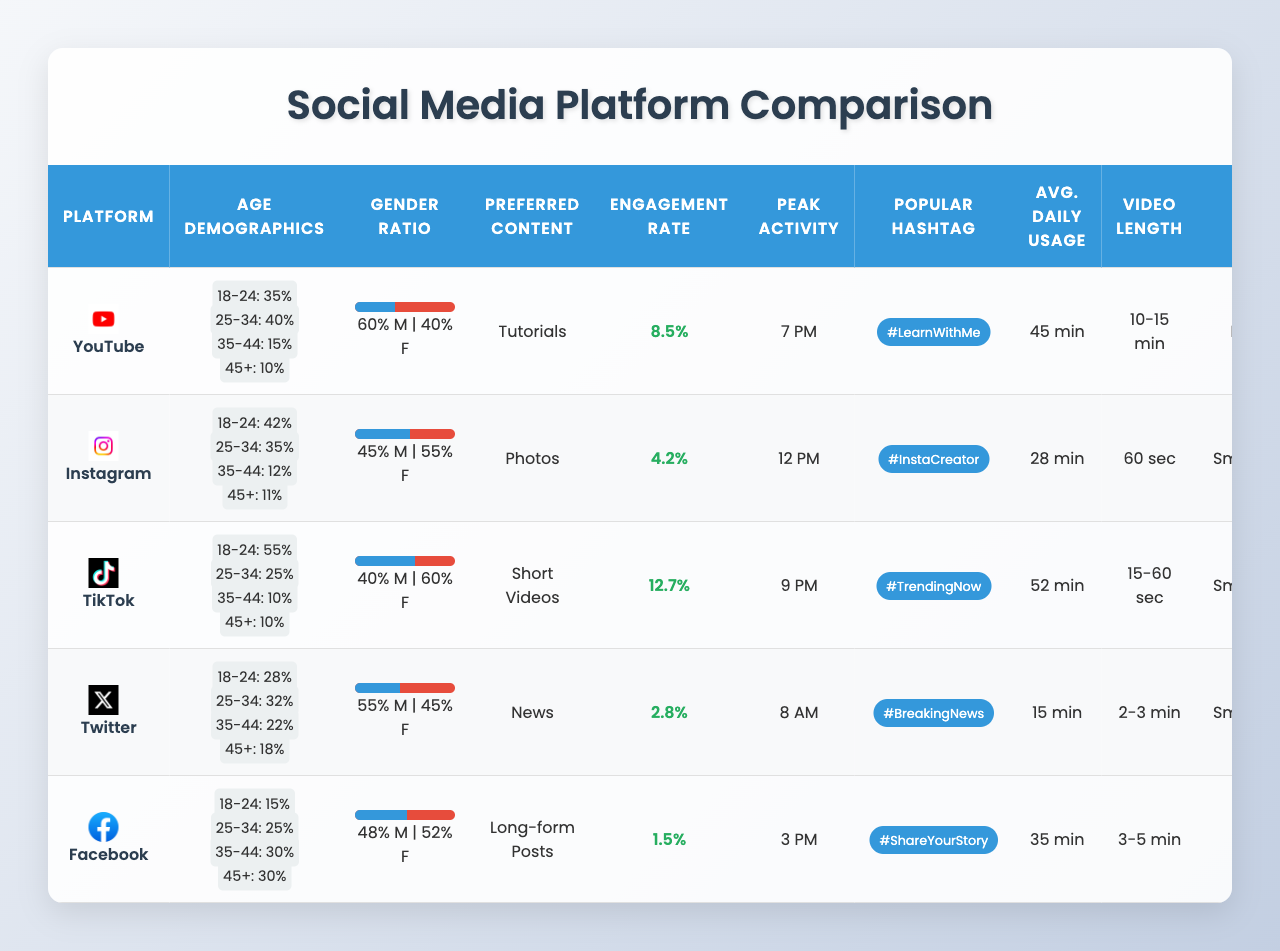What is the average engagement rate across all platforms? To find the average engagement rate, sum all the individual engagement rates (8.5 + 4.2 + 12.7 + 2.8 + 1.5 = 29.7) and then divide by the number of platforms (5). Therefore, the average engagement rate is 29.7 / 5 = 5.94.
Answer: 5.94 Which platform has the highest percentage of international followers? Looking at the "Percentage International Followers" column, TikTok has the highest percentage at 40%.
Answer: 40% What type of content is preferred on Instagram? The preferred content type for Instagram is "Photos," as indicated in the relevant column.
Answer: Photos Is the engagement rate on Facebook higher than that on Twitter? The engagement rate for Facebook is 1.5%, while for Twitter, it is 2.8%. Since 1.5% is lower than 2.8%, the statement is false.
Answer: No Which platform has the lowest average time spent daily by users? By reviewing the "Avg Time Spent Daily Minutes" column, Twitter has the lowest at 15 minutes.
Answer: 15 What is the total percentage of the 18-24 age group on YouTube and TikTok combined? The percentage for YouTube is 35% and for TikTok is 55%. Adding these gives 35 + 55 = 90%.
Answer: 90% Is the majority gender on YouTube male or female? On YouTube, the male percentage is 60%, while the female percentage is 40%. Therefore, the majority gender is male.
Answer: Male How do the video length preferences differ between Instagram and YouTube? Instagram prefers "60 sec" video length, while YouTube prefers "10-15 min" videos. The difference is in the duration, with YouTube favoring significantly longer content.
Answer: Varies Which platform has a peak activity time of 9 PM? The peak activity time of 9 PM is associated with TikTok.
Answer: TikTok Calculate the difference in male percentages between Instagram and Facebook. Instagram has 45% male followers, and Facebook has 48%. The difference is 48 - 45 = 3%.
Answer: 3% 